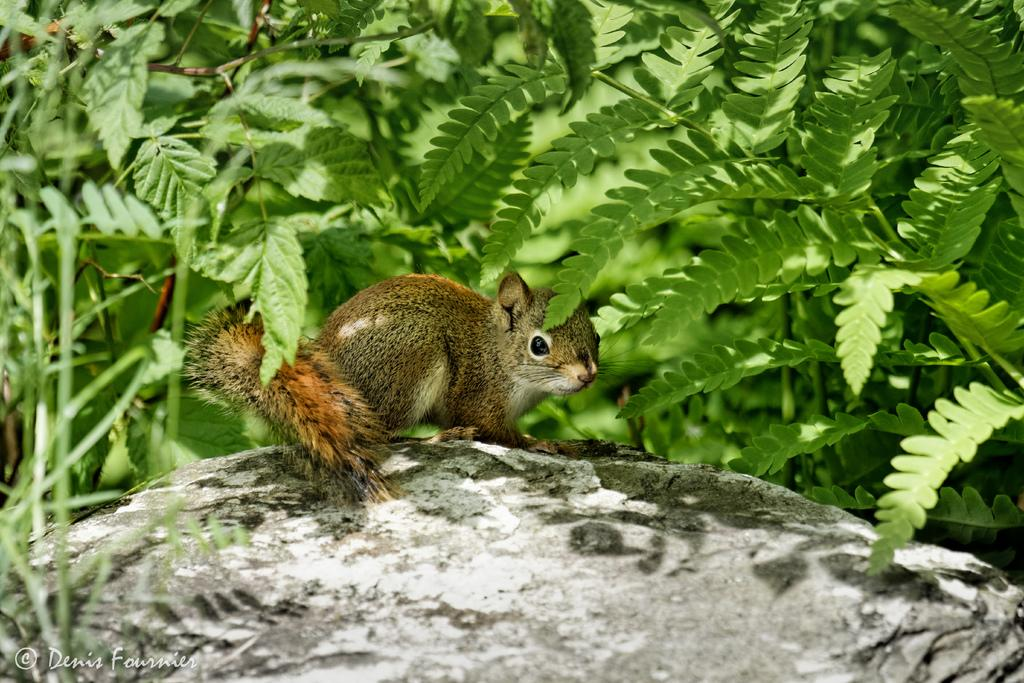What animal is present in the image? There is a squirrel in the image. Where is the squirrel located? The squirrel is on a stone. What can be seen in the background of the image? There are leaves of different plants in the background of the image. What type of flesh can be seen on the squirrel's body in the image? There is no flesh visible on the squirrel's body in the image; it is covered in fur. 